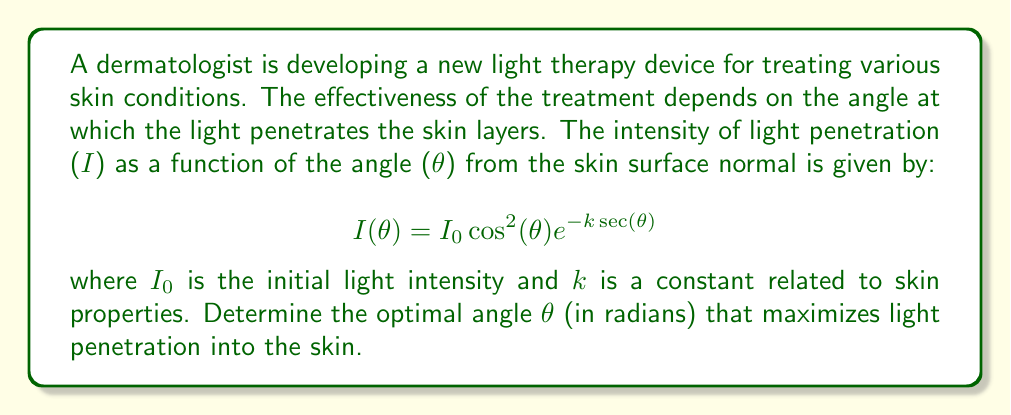Give your solution to this math problem. To find the optimal angle for maximum light penetration, we need to find the maximum of the function $I(\theta)$. This can be done by finding where the derivative of $I(\theta)$ equals zero.

1. First, let's take the derivative of $I(\theta)$ with respect to $\theta$:

   $$\frac{dI}{d\theta} = I_0 \left[-2\cos(\theta)\sin(\theta)e^{-k\sec(\theta)} + \cos^2(\theta)e^{-k\sec(\theta)} \cdot k\sec(\theta)\tan(\theta)\right]$$

2. Set this equal to zero and factor out common terms:

   $$I_0 \cos(\theta) e^{-k\sec(\theta)} [-2\sin(\theta) + k\sec(\theta)\tan(\theta)\cos(\theta)] = 0$$

3. The term $I_0 \cos(\theta) e^{-k\sec(\theta)}$ is always positive for $\theta \in (-\frac{\pi}{2}, \frac{\pi}{2})$, so we can focus on solving:

   $$-2\sin(\theta) + k\sec(\theta)\tan(\theta)\cos(\theta) = 0$$

4. Simplify using trigonometric identities:

   $$-2\sin(\theta) + k\sin(\theta) = 0$$
   $$(k-2)\sin(\theta) = 0$$

5. This equation is satisfied when either $\sin(\theta) = 0$ or $k = 2$. Since $k$ is a constant related to skin properties, we focus on $\sin(\theta) = 0$.

6. The solution to $\sin(\theta) = 0$ in the interval $(-\frac{\pi}{2}, \frac{\pi}{2})$ is $\theta = 0$.

7. To confirm this is a maximum (not a minimum), we can check the second derivative at $\theta = 0$, which should be negative for a maximum.

Therefore, the optimal angle for light penetration is perpendicular to the skin surface, i.e., $\theta = 0$ radians.
Answer: The optimal angle for light penetration is $\theta = 0$ radians, which corresponds to light directed perpendicular to the skin surface. 